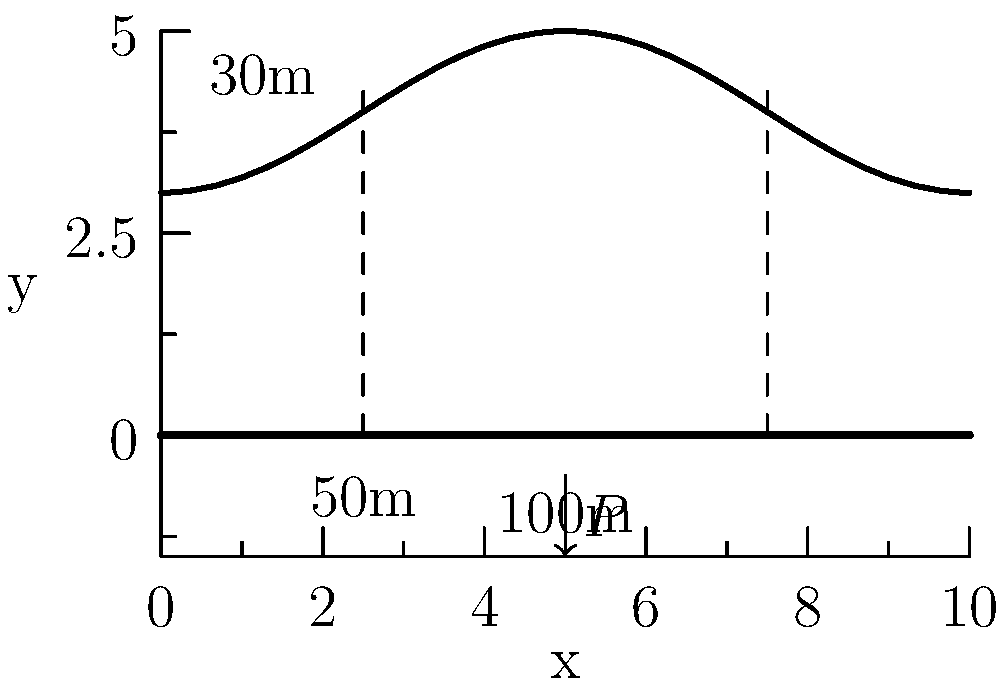As an investigative journalist researching infrastructure safety, you're analyzing a suspension bridge design. The bridge has a main span of 100m and a cable sag of 30m at midspan. A concentrated load $P$ is applied at the center of the deck. Assuming the cable takes all the vertical load, what is the ratio of the horizontal component of cable tension ($H$) to the applied load $P$? To solve this problem, we'll follow these steps:

1) In a suspension bridge, the cable profile approximates a parabola. The equation for a parabolic cable is:

   $$y = \frac{4h}{L^2}x(L-x)$$

   where $h$ is the sag and $L$ is the span length.

2) The horizontal component of cable tension ($H$) is related to the applied load ($P$) and cable geometry by:

   $$H = \frac{PL^2}{8h}$$

3) Given:
   - Span length $L = 100m$
   - Sag $h = 30m$
   - Load $P$ applied at midspan

4) Substituting these values into the equation:

   $$H = \frac{P(100)^2}{8(30)}$$

5) Simplifying:

   $$H = \frac{10000P}{240} = \frac{125P}{3}$$

6) The ratio of $H$ to $P$ is therefore:

   $$\frac{H}{P} = \frac{125}{3} \approx 41.67$$

This ratio indicates that the horizontal cable tension is about 41.67 times the applied load, demonstrating the significant forces at play in suspension bridge design.
Answer: $\frac{H}{P} = \frac{125}{3}$ or approximately 41.67 